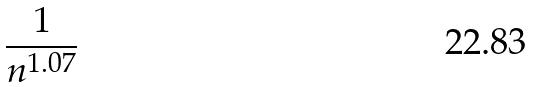<formula> <loc_0><loc_0><loc_500><loc_500>\frac { 1 } { n ^ { 1 . 0 7 } }</formula> 